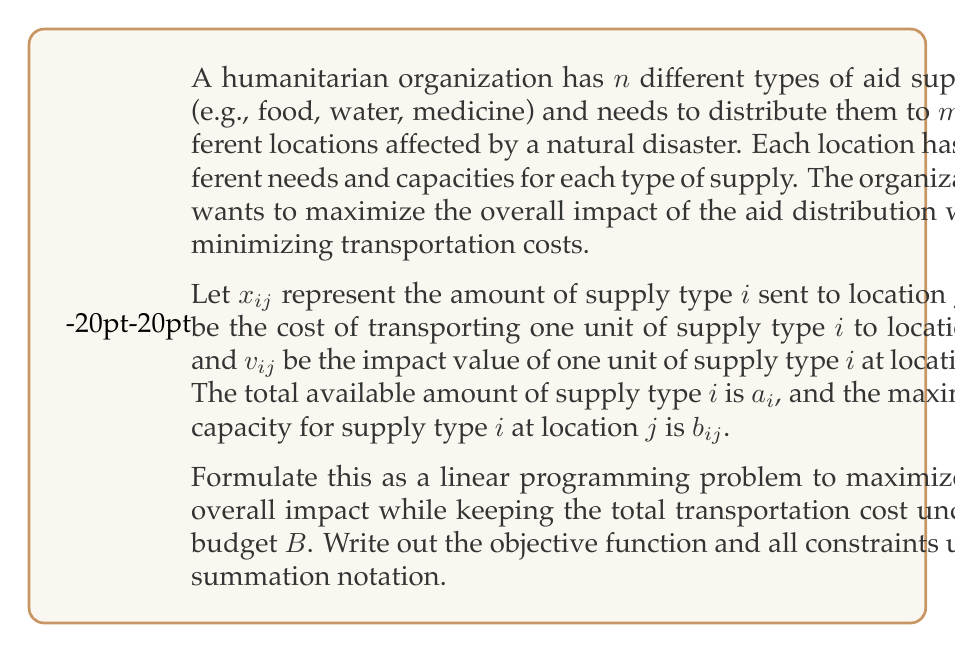Help me with this question. To formulate this as a linear programming problem, we need to define the objective function and the constraints:

1. Objective Function:
   We want to maximize the overall impact of the aid distribution. The impact of sending $x_{ij}$ units of supply type $i$ to location $j$ is $v_{ij}x_{ij}$. Therefore, the total impact across all supply types and locations is:

   $$\text{Maximize } \sum_{i=1}^n \sum_{j=1}^m v_{ij}x_{ij}$$

2. Constraints:
   a) Budget constraint: The total transportation cost must not exceed the budget $B$.
      $$\sum_{i=1}^n \sum_{j=1}^m c_{ij}x_{ij} \leq B$$

   b) Supply constraints: For each supply type $i$, the total amount distributed cannot exceed the available amount $a_i$.
      $$\sum_{j=1}^m x_{ij} \leq a_i \quad \text{for } i = 1, 2, ..., n$$

   c) Capacity constraints: For each location $j$ and supply type $i$, the amount sent cannot exceed the maximum capacity $b_{ij}$.
      $$x_{ij} \leq b_{ij} \quad \text{for } i = 1, 2, ..., n \text{ and } j = 1, 2, ..., m$$

   d) Non-negativity constraints: The amount of supplies sent must be non-negative.
      $$x_{ij} \geq 0 \quad \text{for } i = 1, 2, ..., n \text{ and } j = 1, 2, ..., m$$

Combining all these elements, we get the complete linear programming formulation:

$$
\begin{align*}
\text{Maximize } & \sum_{i=1}^n \sum_{j=1}^m v_{ij}x_{ij} \\
\text{Subject to: } & \\
& \sum_{i=1}^n \sum_{j=1}^m c_{ij}x_{ij} \leq B \\
& \sum_{j=1}^m x_{ij} \leq a_i \quad \text{for } i = 1, 2, ..., n \\
& x_{ij} \leq b_{ij} \quad \text{for } i = 1, 2, ..., n \text{ and } j = 1, 2, ..., m \\
& x_{ij} \geq 0 \quad \text{for } i = 1, 2, ..., n \text{ and } j = 1, 2, ..., m
\end{align*}
$$

This formulation allows for the efficient allocation of resources in humanitarian aid, considering the impact of each supply type at different locations, transportation costs, and various constraints. Solving this linear programming problem would provide the optimal distribution of supplies to maximize impact while staying within the budget.
Answer: The linear programming formulation for maximizing the impact of humanitarian aid distribution while considering budget and capacity constraints is:

$$
\begin{align*}
\text{Maximize } & \sum_{i=1}^n \sum_{j=1}^m v_{ij}x_{ij} \\
\text{Subject to: } & \\
& \sum_{i=1}^n \sum_{j=1}^m c_{ij}x_{ij} \leq B \\
& \sum_{j=1}^m x_{ij} \leq a_i \quad \text{for } i = 1, 2, ..., n \\
& x_{ij} \leq b_{ij} \quad \text{for } i = 1, 2, ..., n \text{ and } j = 1, 2, ..., m \\
& x_{ij} \geq 0 \quad \text{for } i = 1, 2, ..., n \text{ and } j = 1, 2, ..., m
\end{align*}
$$ 